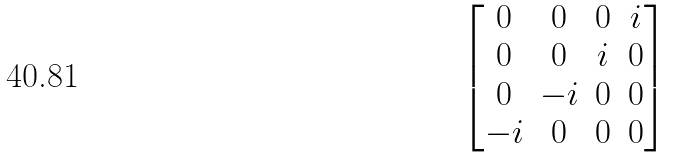Convert formula to latex. <formula><loc_0><loc_0><loc_500><loc_500>\begin{bmatrix} 0 & 0 & 0 & i \\ 0 & 0 & i & 0 \\ 0 & - i & 0 & 0 \\ - i & 0 & 0 & 0 \\ \end{bmatrix}</formula> 